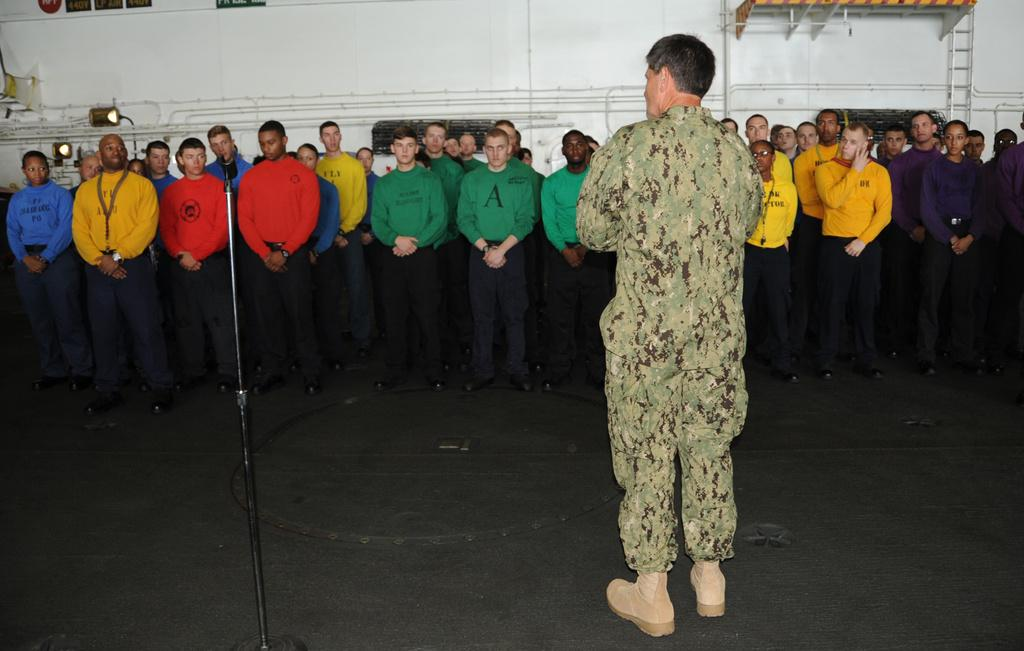What is the main subject of the image? The main subject of the image is a group of people. What are the people in the image doing? The people are standing. What can be seen on the floor in the image? There is a stand on the floor in the image. What is visible in the background of the image? There is a wall in the background of the image. What type of beast can be seen interacting with the people in the image? There is no beast present in the image; it only features a group of people standing and a stand on the floor. 